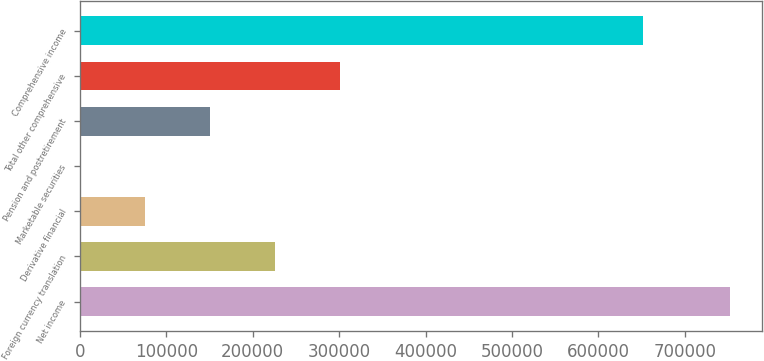Convert chart. <chart><loc_0><loc_0><loc_500><loc_500><bar_chart><fcel>Net income<fcel>Foreign currency translation<fcel>Derivative financial<fcel>Marketable securities<fcel>Pension and postretirement<fcel>Total other comprehensive<fcel>Comprehensive income<nl><fcel>752207<fcel>225938<fcel>75575.3<fcel>394<fcel>150757<fcel>301119<fcel>651945<nl></chart> 